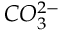Convert formula to latex. <formula><loc_0><loc_0><loc_500><loc_500>C O _ { 3 } ^ { 2 - }</formula> 